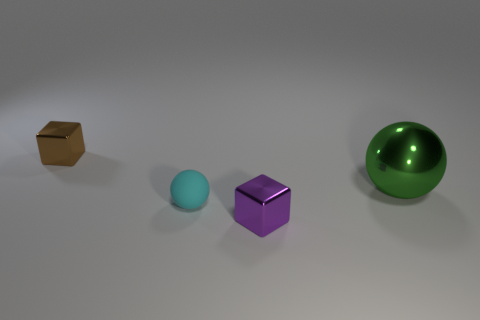Add 3 tiny rubber balls. How many objects exist? 7 Subtract 0 yellow balls. How many objects are left? 4 Subtract all big green matte cylinders. Subtract all tiny brown objects. How many objects are left? 3 Add 4 cyan balls. How many cyan balls are left? 5 Add 3 green shiny balls. How many green shiny balls exist? 4 